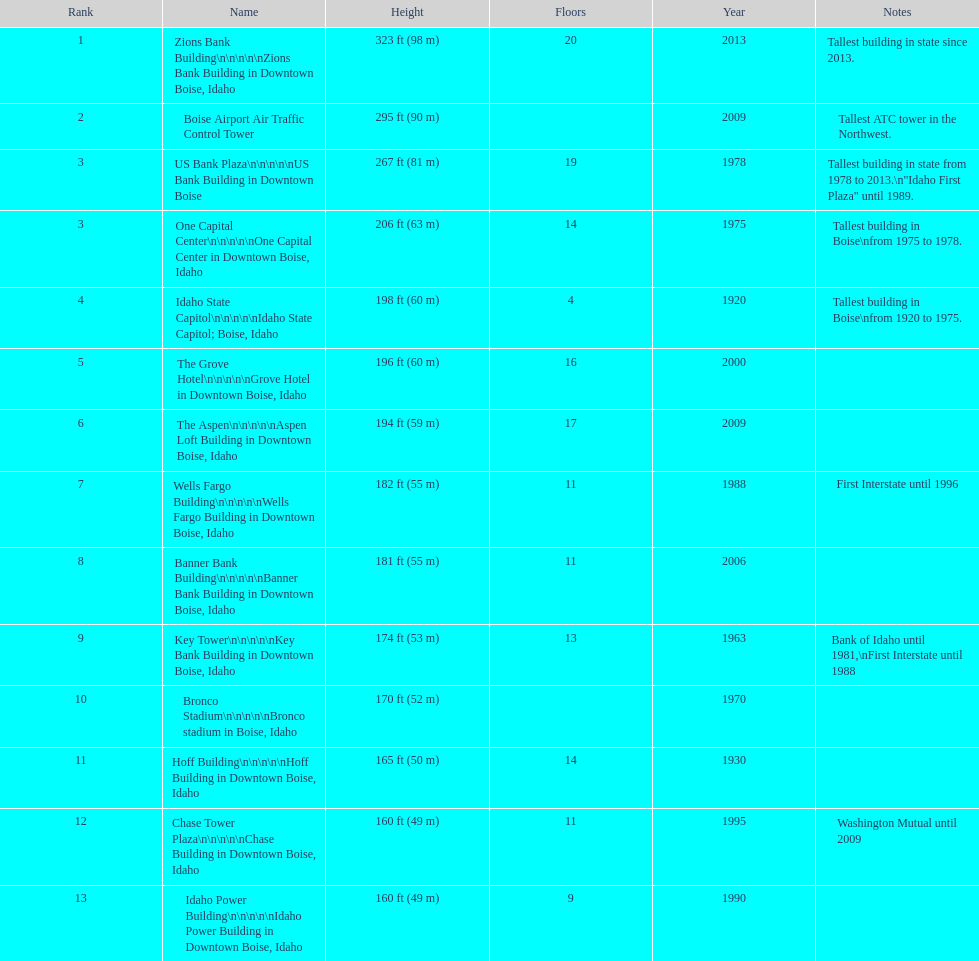Which building has the most floors according to this chart? Zions Bank Building. 